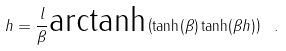<formula> <loc_0><loc_0><loc_500><loc_500>h = \frac { l } { \beta } \text {arctanh} \left ( \tanh ( \beta ) \tanh ( \beta h ) \right ) \ .</formula> 